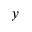Convert formula to latex. <formula><loc_0><loc_0><loc_500><loc_500>y</formula> 